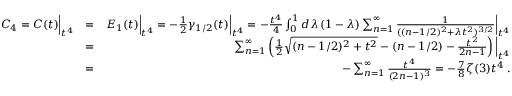Convert formula to latex. <formula><loc_0><loc_0><loc_500><loc_500>\begin{array} { r l r } { C _ { 4 } = C ( t ) \Big | _ { t ^ { 4 } } } & { = } & { E _ { 1 } ( t ) \Big | _ { t ^ { 4 } } = - { \frac { 1 } { 2 } } \gamma _ { 1 / 2 } ( t ) \Big | _ { t ^ { 4 } } = - { \frac { t ^ { 4 } } { 4 } } \int _ { 0 } ^ { 1 } d \lambda \, ( 1 - \lambda ) \sum _ { n = 1 } ^ { \infty } { \frac { 1 } { ( ( n - 1 / 2 ) ^ { 2 } + \lambda t ^ { 2 } ) ^ { 3 / 2 } } } \Big | _ { t ^ { 4 } } } \\ & { = } & { \sum _ { n = 1 } ^ { \infty } \left ( { \frac { 1 } { 2 } } \sqrt { ( n - 1 / 2 ) ^ { 2 } + t ^ { 2 } } - ( n - 1 / 2 ) - { \frac { t ^ { 2 } } { 2 n - 1 } } \right ) \Big | _ { t ^ { 4 } } } \\ & { = } & { - \sum _ { n = 1 } ^ { \infty } { \frac { t ^ { 4 } } { ( 2 n - 1 ) ^ { 3 } } } = - { \frac { 7 } { 8 } } \zeta ( 3 ) t ^ { 4 } \, . } \end{array}</formula> 